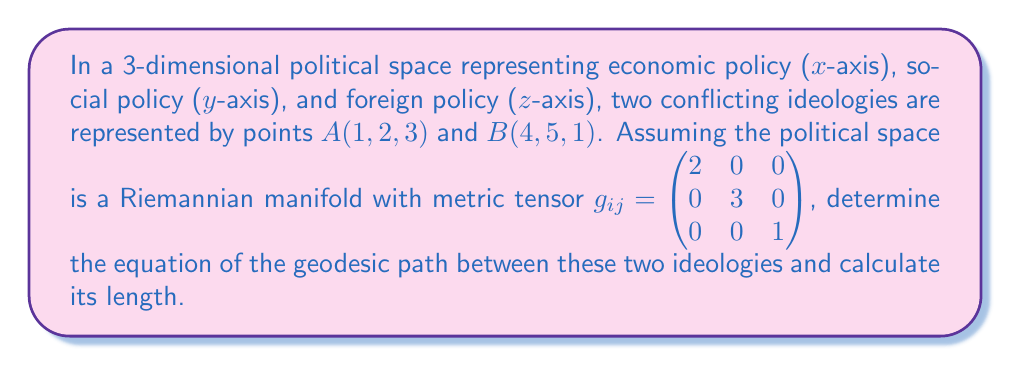Can you solve this math problem? 1. In a Riemannian manifold, the geodesic between two points is the path of shortest distance. For a flat space with a constant metric tensor, the geodesic is a straight line.

2. The parametric equation of a straight line from A to B is:
   $$r(t) = (1-t)A + tB, \quad 0 \leq t \leq 1$$

3. Substituting the coordinates:
   $$r(t) = (1-t)(1,2,3) + t(4,5,1)$$
   $$r(t) = (1+3t, 2+3t, 3-2t)$$

4. The tangent vector to this curve is:
   $$\frac{dr}{dt} = (3, 3, -2)$$

5. The length of the geodesic is given by the integral:
   $$L = \int_0^1 \sqrt{\left(\frac{dr}{dt}\right)^T g \left(\frac{dr}{dt}\right)} dt$$

6. Calculating the quadratic form inside the square root:
   $$\begin{pmatrix} 3 & 3 & -2 \end{pmatrix} \begin{pmatrix} 2 & 0 & 0 \\ 0 & 3 & 0 \\ 0 & 0 & 1 \end{pmatrix} \begin{pmatrix} 3 \\ 3 \\ -2 \end{pmatrix} = 18 + 27 + 4 = 49$$

7. Therefore, the length of the geodesic is:
   $$L = \int_0^1 \sqrt{49} dt = 7$$
Answer: Geodesic equation: $r(t) = (1+3t, 2+3t, 3-2t)$, Length: 7 